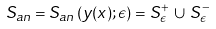<formula> <loc_0><loc_0><loc_500><loc_500>S _ { a n } = S _ { a n } \left ( y ( x ) ; \epsilon \right ) = S ^ { + } _ { \epsilon } \, \cup \, S ^ { - } _ { \epsilon }</formula> 